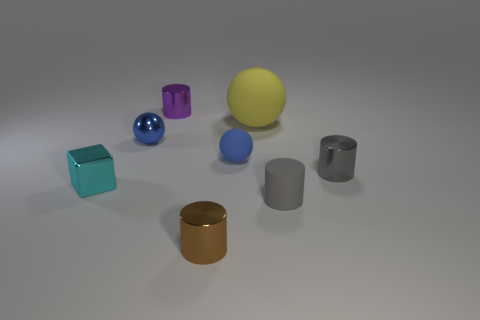Subtract all purple cylinders. How many cylinders are left? 3 Add 2 small cylinders. How many objects exist? 10 Subtract all blue balls. How many balls are left? 1 Subtract all yellow cubes. How many gray cylinders are left? 2 Subtract all blocks. How many objects are left? 7 Subtract 1 cylinders. How many cylinders are left? 3 Subtract all blue metallic things. Subtract all gray things. How many objects are left? 5 Add 4 big rubber balls. How many big rubber balls are left? 5 Add 2 small brown metal objects. How many small brown metal objects exist? 3 Subtract 0 brown spheres. How many objects are left? 8 